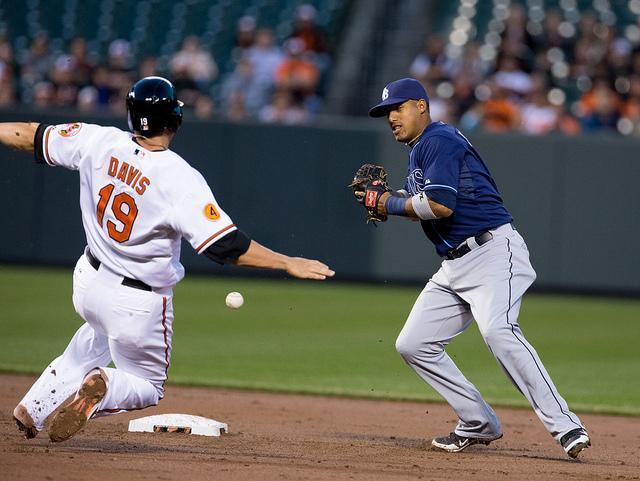How many people are visible?
Give a very brief answer. 2. How many people are driving a motorcycle in this image?
Give a very brief answer. 0. 